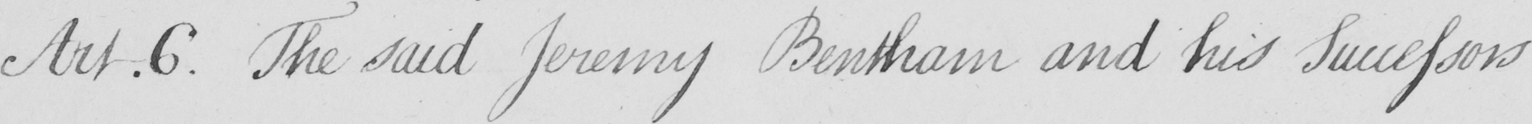What is written in this line of handwriting? Art.6 . The said Jeremy Bentham and his Successors 